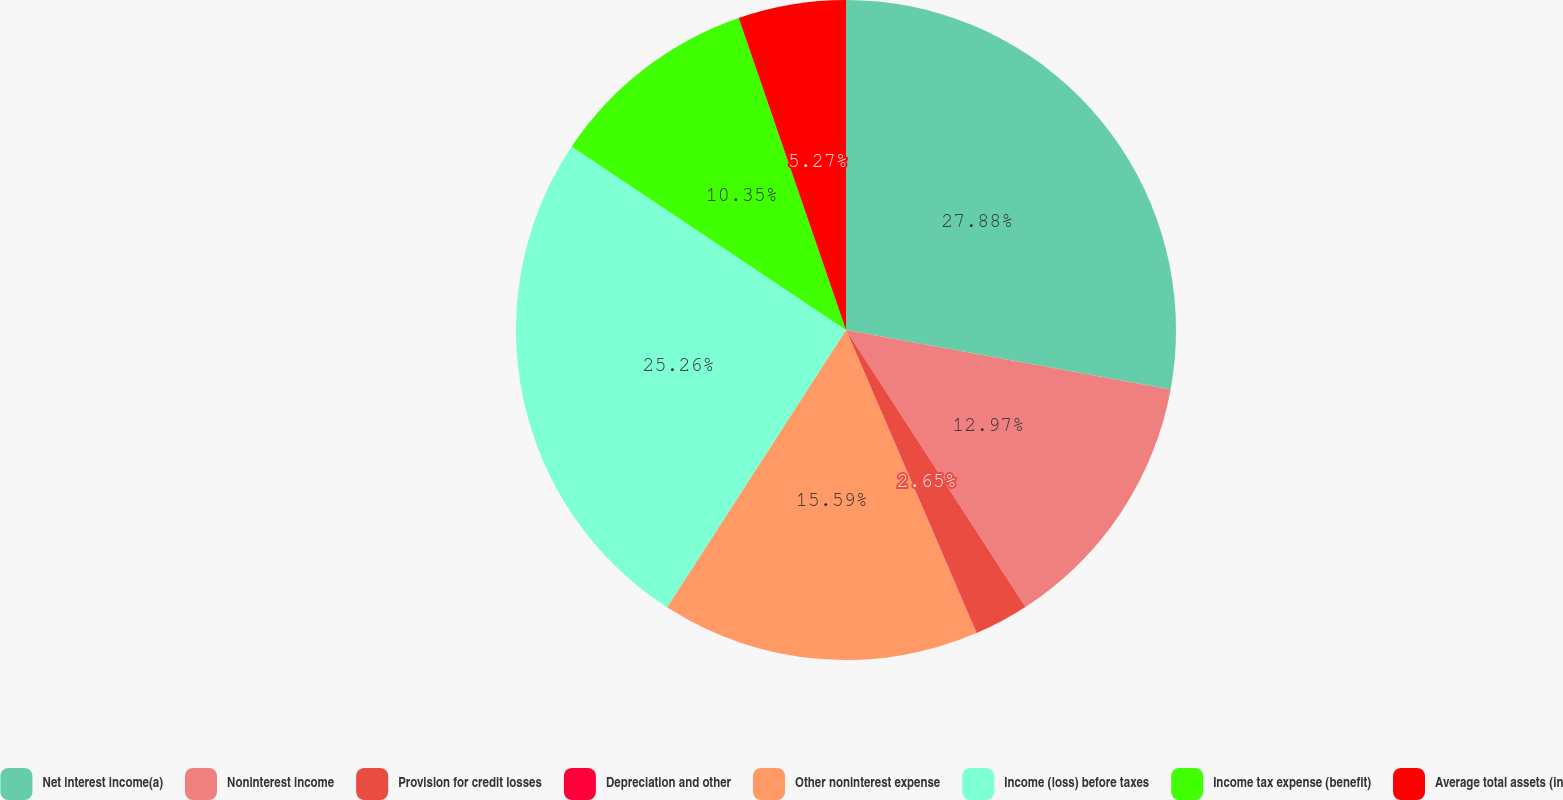<chart> <loc_0><loc_0><loc_500><loc_500><pie_chart><fcel>Net interest income(a)<fcel>Noninterest income<fcel>Provision for credit losses<fcel>Depreciation and other<fcel>Other noninterest expense<fcel>Income (loss) before taxes<fcel>Income tax expense (benefit)<fcel>Average total assets (in<nl><fcel>27.88%<fcel>12.97%<fcel>2.65%<fcel>0.03%<fcel>15.59%<fcel>25.26%<fcel>10.35%<fcel>5.27%<nl></chart> 